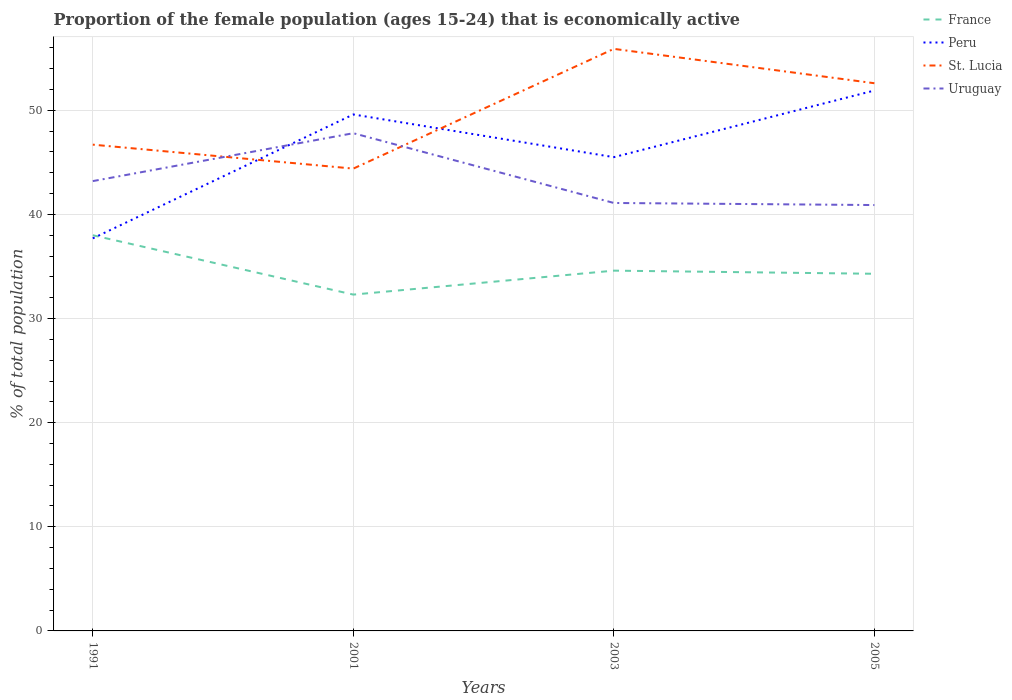Is the number of lines equal to the number of legend labels?
Keep it short and to the point. Yes. Across all years, what is the maximum proportion of the female population that is economically active in St. Lucia?
Your answer should be very brief. 44.4. In which year was the proportion of the female population that is economically active in St. Lucia maximum?
Your answer should be compact. 2001. What is the total proportion of the female population that is economically active in Uruguay in the graph?
Provide a short and direct response. -4.6. What is the difference between the highest and the second highest proportion of the female population that is economically active in Peru?
Make the answer very short. 14.2. How many years are there in the graph?
Provide a succinct answer. 4. What is the difference between two consecutive major ticks on the Y-axis?
Your answer should be compact. 10. Does the graph contain any zero values?
Your answer should be compact. No. How are the legend labels stacked?
Offer a very short reply. Vertical. What is the title of the graph?
Your answer should be compact. Proportion of the female population (ages 15-24) that is economically active. What is the label or title of the Y-axis?
Offer a terse response. % of total population. What is the % of total population in France in 1991?
Provide a succinct answer. 38. What is the % of total population in Peru in 1991?
Provide a short and direct response. 37.7. What is the % of total population of St. Lucia in 1991?
Your answer should be compact. 46.7. What is the % of total population of Uruguay in 1991?
Give a very brief answer. 43.2. What is the % of total population of France in 2001?
Ensure brevity in your answer.  32.3. What is the % of total population in Peru in 2001?
Provide a succinct answer. 49.6. What is the % of total population in St. Lucia in 2001?
Your answer should be very brief. 44.4. What is the % of total population in Uruguay in 2001?
Keep it short and to the point. 47.8. What is the % of total population of France in 2003?
Offer a very short reply. 34.6. What is the % of total population of Peru in 2003?
Give a very brief answer. 45.5. What is the % of total population of St. Lucia in 2003?
Offer a terse response. 55.9. What is the % of total population in Uruguay in 2003?
Give a very brief answer. 41.1. What is the % of total population of France in 2005?
Ensure brevity in your answer.  34.3. What is the % of total population of Peru in 2005?
Give a very brief answer. 51.9. What is the % of total population of St. Lucia in 2005?
Provide a short and direct response. 52.6. What is the % of total population of Uruguay in 2005?
Ensure brevity in your answer.  40.9. Across all years, what is the maximum % of total population in France?
Your answer should be very brief. 38. Across all years, what is the maximum % of total population in Peru?
Ensure brevity in your answer.  51.9. Across all years, what is the maximum % of total population in St. Lucia?
Offer a very short reply. 55.9. Across all years, what is the maximum % of total population in Uruguay?
Your answer should be very brief. 47.8. Across all years, what is the minimum % of total population of France?
Keep it short and to the point. 32.3. Across all years, what is the minimum % of total population of Peru?
Provide a succinct answer. 37.7. Across all years, what is the minimum % of total population in St. Lucia?
Make the answer very short. 44.4. Across all years, what is the minimum % of total population of Uruguay?
Give a very brief answer. 40.9. What is the total % of total population in France in the graph?
Make the answer very short. 139.2. What is the total % of total population of Peru in the graph?
Keep it short and to the point. 184.7. What is the total % of total population in St. Lucia in the graph?
Your answer should be compact. 199.6. What is the total % of total population in Uruguay in the graph?
Give a very brief answer. 173. What is the difference between the % of total population in Peru in 1991 and that in 2001?
Give a very brief answer. -11.9. What is the difference between the % of total population of St. Lucia in 1991 and that in 2001?
Your answer should be compact. 2.3. What is the difference between the % of total population in Peru in 1991 and that in 2003?
Your answer should be compact. -7.8. What is the difference between the % of total population of St. Lucia in 1991 and that in 2003?
Give a very brief answer. -9.2. What is the difference between the % of total population of Peru in 1991 and that in 2005?
Provide a succinct answer. -14.2. What is the difference between the % of total population of France in 2001 and that in 2003?
Your answer should be very brief. -2.3. What is the difference between the % of total population of Peru in 2001 and that in 2003?
Provide a succinct answer. 4.1. What is the difference between the % of total population in St. Lucia in 2001 and that in 2003?
Give a very brief answer. -11.5. What is the difference between the % of total population of Uruguay in 2001 and that in 2003?
Offer a very short reply. 6.7. What is the difference between the % of total population of France in 2001 and that in 2005?
Offer a terse response. -2. What is the difference between the % of total population of France in 2003 and that in 2005?
Provide a succinct answer. 0.3. What is the difference between the % of total population in Uruguay in 2003 and that in 2005?
Keep it short and to the point. 0.2. What is the difference between the % of total population in France in 1991 and the % of total population in Peru in 2001?
Give a very brief answer. -11.6. What is the difference between the % of total population in Peru in 1991 and the % of total population in St. Lucia in 2001?
Offer a terse response. -6.7. What is the difference between the % of total population in St. Lucia in 1991 and the % of total population in Uruguay in 2001?
Ensure brevity in your answer.  -1.1. What is the difference between the % of total population of France in 1991 and the % of total population of Peru in 2003?
Keep it short and to the point. -7.5. What is the difference between the % of total population in France in 1991 and the % of total population in St. Lucia in 2003?
Give a very brief answer. -17.9. What is the difference between the % of total population in Peru in 1991 and the % of total population in St. Lucia in 2003?
Provide a succinct answer. -18.2. What is the difference between the % of total population in France in 1991 and the % of total population in St. Lucia in 2005?
Offer a very short reply. -14.6. What is the difference between the % of total population in France in 1991 and the % of total population in Uruguay in 2005?
Your answer should be compact. -2.9. What is the difference between the % of total population in Peru in 1991 and the % of total population in St. Lucia in 2005?
Offer a terse response. -14.9. What is the difference between the % of total population of St. Lucia in 1991 and the % of total population of Uruguay in 2005?
Your response must be concise. 5.8. What is the difference between the % of total population of France in 2001 and the % of total population of Peru in 2003?
Your answer should be compact. -13.2. What is the difference between the % of total population of France in 2001 and the % of total population of St. Lucia in 2003?
Provide a succinct answer. -23.6. What is the difference between the % of total population in France in 2001 and the % of total population in Uruguay in 2003?
Give a very brief answer. -8.8. What is the difference between the % of total population in Peru in 2001 and the % of total population in Uruguay in 2003?
Provide a short and direct response. 8.5. What is the difference between the % of total population of France in 2001 and the % of total population of Peru in 2005?
Your response must be concise. -19.6. What is the difference between the % of total population of France in 2001 and the % of total population of St. Lucia in 2005?
Provide a short and direct response. -20.3. What is the difference between the % of total population in France in 2001 and the % of total population in Uruguay in 2005?
Give a very brief answer. -8.6. What is the difference between the % of total population of St. Lucia in 2001 and the % of total population of Uruguay in 2005?
Make the answer very short. 3.5. What is the difference between the % of total population in France in 2003 and the % of total population in Peru in 2005?
Ensure brevity in your answer.  -17.3. What is the difference between the % of total population of France in 2003 and the % of total population of Uruguay in 2005?
Your response must be concise. -6.3. What is the difference between the % of total population of Peru in 2003 and the % of total population of Uruguay in 2005?
Make the answer very short. 4.6. What is the average % of total population of France per year?
Provide a short and direct response. 34.8. What is the average % of total population in Peru per year?
Make the answer very short. 46.17. What is the average % of total population in St. Lucia per year?
Your answer should be very brief. 49.9. What is the average % of total population in Uruguay per year?
Your answer should be compact. 43.25. In the year 1991, what is the difference between the % of total population of France and % of total population of Peru?
Offer a very short reply. 0.3. In the year 1991, what is the difference between the % of total population in France and % of total population in St. Lucia?
Your answer should be very brief. -8.7. In the year 1991, what is the difference between the % of total population of Peru and % of total population of St. Lucia?
Your response must be concise. -9. In the year 1991, what is the difference between the % of total population in Peru and % of total population in Uruguay?
Offer a terse response. -5.5. In the year 2001, what is the difference between the % of total population in France and % of total population in Peru?
Offer a terse response. -17.3. In the year 2001, what is the difference between the % of total population in France and % of total population in Uruguay?
Ensure brevity in your answer.  -15.5. In the year 2001, what is the difference between the % of total population of Peru and % of total population of St. Lucia?
Make the answer very short. 5.2. In the year 2003, what is the difference between the % of total population of France and % of total population of St. Lucia?
Your answer should be compact. -21.3. In the year 2003, what is the difference between the % of total population in Peru and % of total population in Uruguay?
Provide a succinct answer. 4.4. In the year 2003, what is the difference between the % of total population of St. Lucia and % of total population of Uruguay?
Provide a succinct answer. 14.8. In the year 2005, what is the difference between the % of total population of France and % of total population of Peru?
Offer a very short reply. -17.6. In the year 2005, what is the difference between the % of total population of France and % of total population of St. Lucia?
Your response must be concise. -18.3. In the year 2005, what is the difference between the % of total population in France and % of total population in Uruguay?
Keep it short and to the point. -6.6. In the year 2005, what is the difference between the % of total population in Peru and % of total population in Uruguay?
Your response must be concise. 11. What is the ratio of the % of total population of France in 1991 to that in 2001?
Make the answer very short. 1.18. What is the ratio of the % of total population of Peru in 1991 to that in 2001?
Provide a succinct answer. 0.76. What is the ratio of the % of total population in St. Lucia in 1991 to that in 2001?
Your answer should be very brief. 1.05. What is the ratio of the % of total population in Uruguay in 1991 to that in 2001?
Make the answer very short. 0.9. What is the ratio of the % of total population of France in 1991 to that in 2003?
Offer a very short reply. 1.1. What is the ratio of the % of total population of Peru in 1991 to that in 2003?
Provide a succinct answer. 0.83. What is the ratio of the % of total population of St. Lucia in 1991 to that in 2003?
Your answer should be compact. 0.84. What is the ratio of the % of total population in Uruguay in 1991 to that in 2003?
Offer a very short reply. 1.05. What is the ratio of the % of total population in France in 1991 to that in 2005?
Keep it short and to the point. 1.11. What is the ratio of the % of total population in Peru in 1991 to that in 2005?
Offer a very short reply. 0.73. What is the ratio of the % of total population in St. Lucia in 1991 to that in 2005?
Keep it short and to the point. 0.89. What is the ratio of the % of total population of Uruguay in 1991 to that in 2005?
Keep it short and to the point. 1.06. What is the ratio of the % of total population of France in 2001 to that in 2003?
Provide a short and direct response. 0.93. What is the ratio of the % of total population in Peru in 2001 to that in 2003?
Make the answer very short. 1.09. What is the ratio of the % of total population of St. Lucia in 2001 to that in 2003?
Offer a terse response. 0.79. What is the ratio of the % of total population in Uruguay in 2001 to that in 2003?
Your answer should be compact. 1.16. What is the ratio of the % of total population of France in 2001 to that in 2005?
Your response must be concise. 0.94. What is the ratio of the % of total population in Peru in 2001 to that in 2005?
Offer a very short reply. 0.96. What is the ratio of the % of total population of St. Lucia in 2001 to that in 2005?
Ensure brevity in your answer.  0.84. What is the ratio of the % of total population of Uruguay in 2001 to that in 2005?
Keep it short and to the point. 1.17. What is the ratio of the % of total population of France in 2003 to that in 2005?
Offer a very short reply. 1.01. What is the ratio of the % of total population in Peru in 2003 to that in 2005?
Provide a short and direct response. 0.88. What is the ratio of the % of total population in St. Lucia in 2003 to that in 2005?
Ensure brevity in your answer.  1.06. What is the ratio of the % of total population of Uruguay in 2003 to that in 2005?
Your response must be concise. 1. What is the difference between the highest and the lowest % of total population in France?
Offer a terse response. 5.7. 